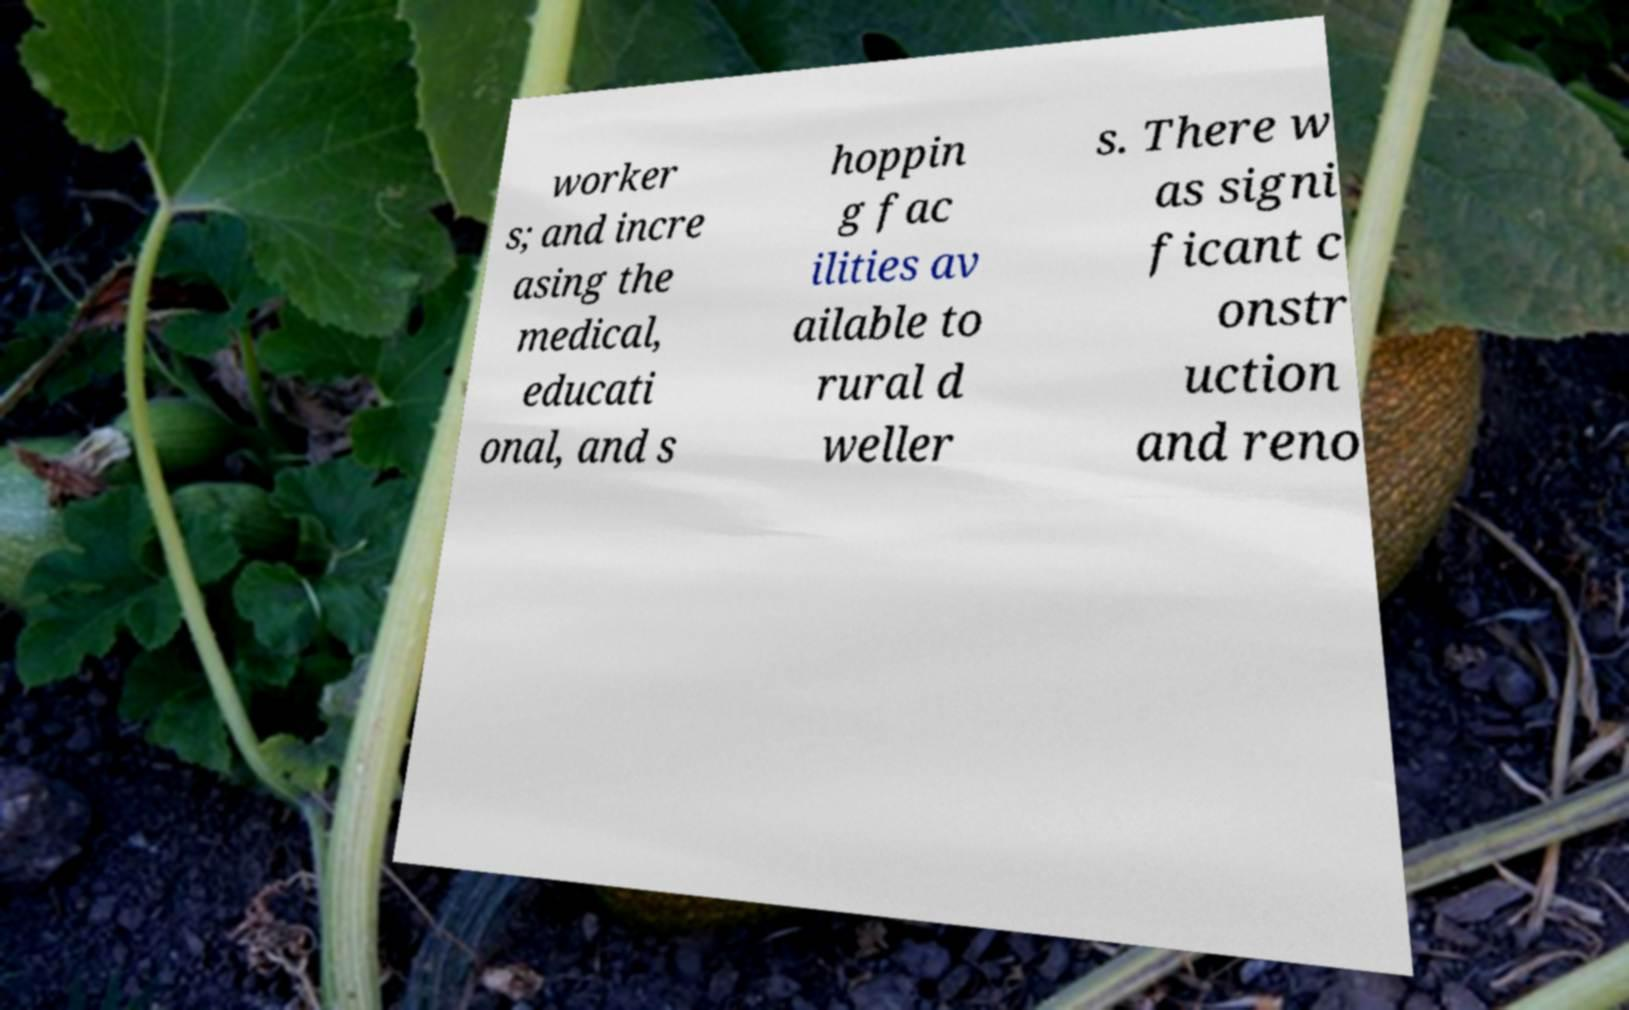Could you assist in decoding the text presented in this image and type it out clearly? worker s; and incre asing the medical, educati onal, and s hoppin g fac ilities av ailable to rural d weller s. There w as signi ficant c onstr uction and reno 